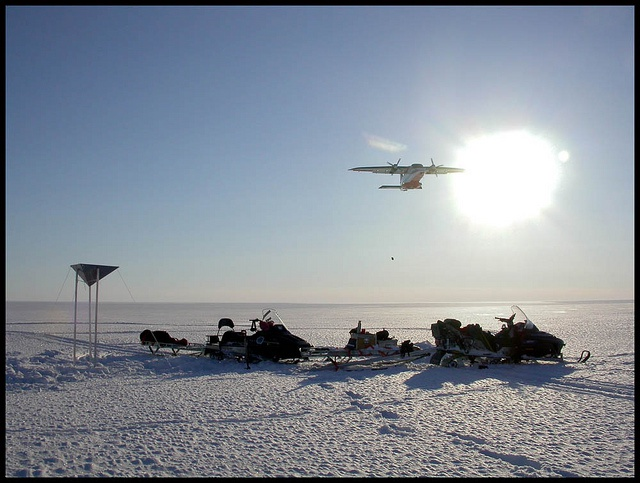Describe the objects in this image and their specific colors. I can see a airplane in black, gray, and darkgray tones in this image. 